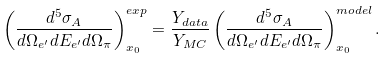Convert formula to latex. <formula><loc_0><loc_0><loc_500><loc_500>\left ( \frac { d ^ { 5 } \sigma _ { A } } { d \Omega _ { e ^ { \prime } } d E _ { e ^ { \prime } } d \Omega _ { \pi } } \right ) ^ { e x p } _ { x _ { 0 } } = \frac { Y _ { d a t a } } { Y _ { M C } } \left ( \frac { d ^ { 5 } \sigma _ { A } } { d \Omega _ { e ^ { \prime } } d E _ { e ^ { \prime } } d \Omega _ { \pi } } \right ) ^ { m o d e l } _ { x _ { 0 } } .</formula> 